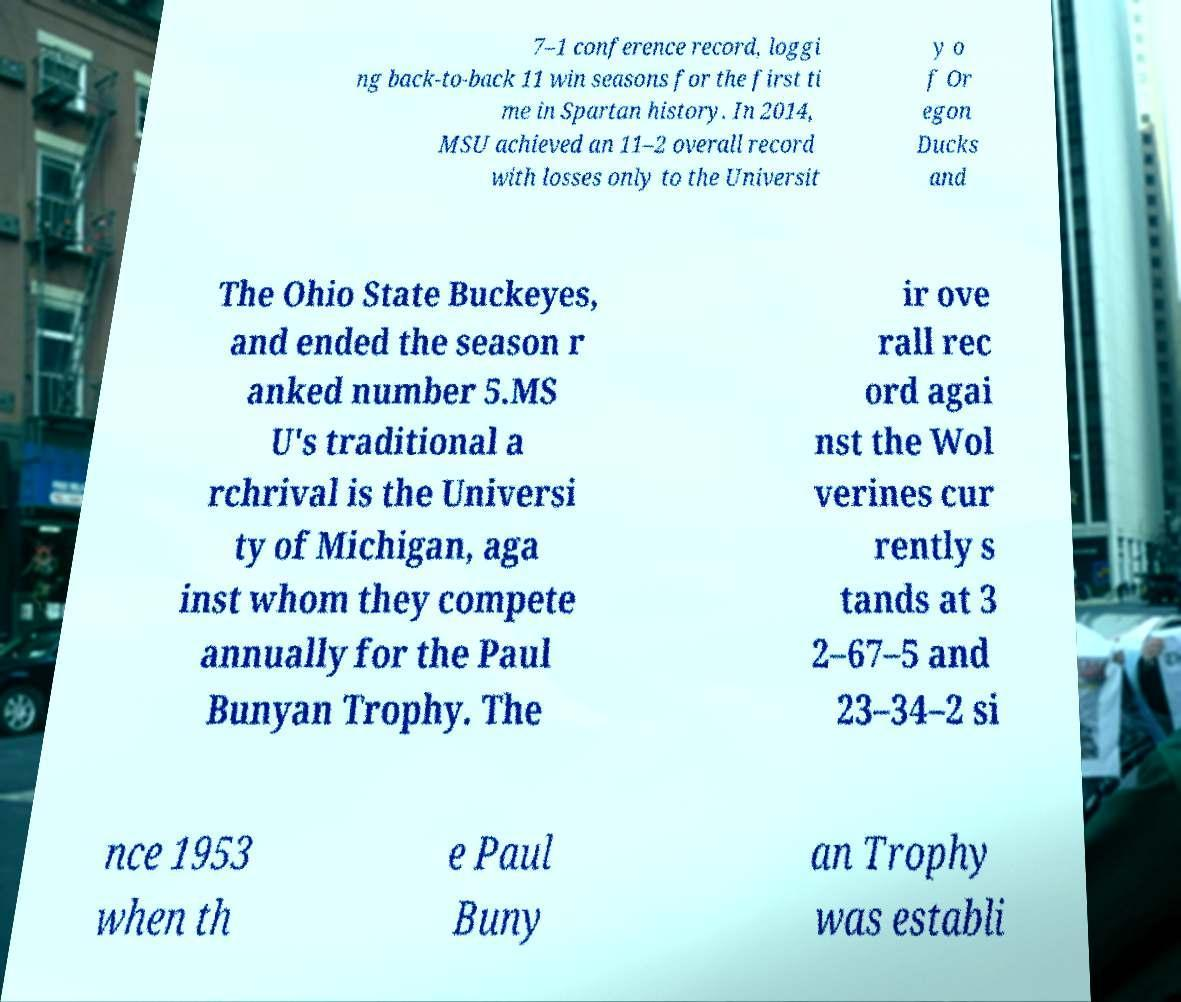Please read and relay the text visible in this image. What does it say? 7–1 conference record, loggi ng back-to-back 11 win seasons for the first ti me in Spartan history. In 2014, MSU achieved an 11–2 overall record with losses only to the Universit y o f Or egon Ducks and The Ohio State Buckeyes, and ended the season r anked number 5.MS U's traditional a rchrival is the Universi ty of Michigan, aga inst whom they compete annually for the Paul Bunyan Trophy. The ir ove rall rec ord agai nst the Wol verines cur rently s tands at 3 2–67–5 and 23–34–2 si nce 1953 when th e Paul Buny an Trophy was establi 